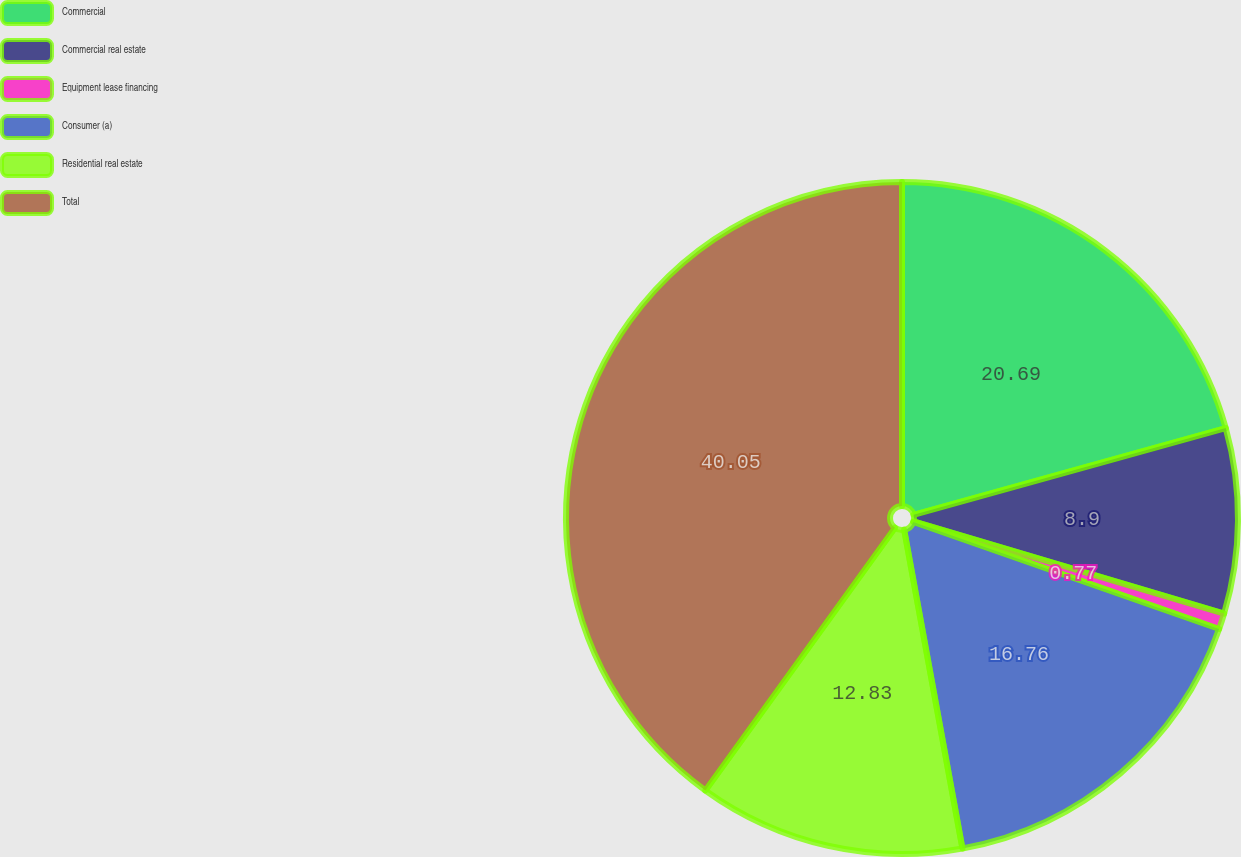<chart> <loc_0><loc_0><loc_500><loc_500><pie_chart><fcel>Commercial<fcel>Commercial real estate<fcel>Equipment lease financing<fcel>Consumer (a)<fcel>Residential real estate<fcel>Total<nl><fcel>20.69%<fcel>8.9%<fcel>0.77%<fcel>16.76%<fcel>12.83%<fcel>40.05%<nl></chart> 